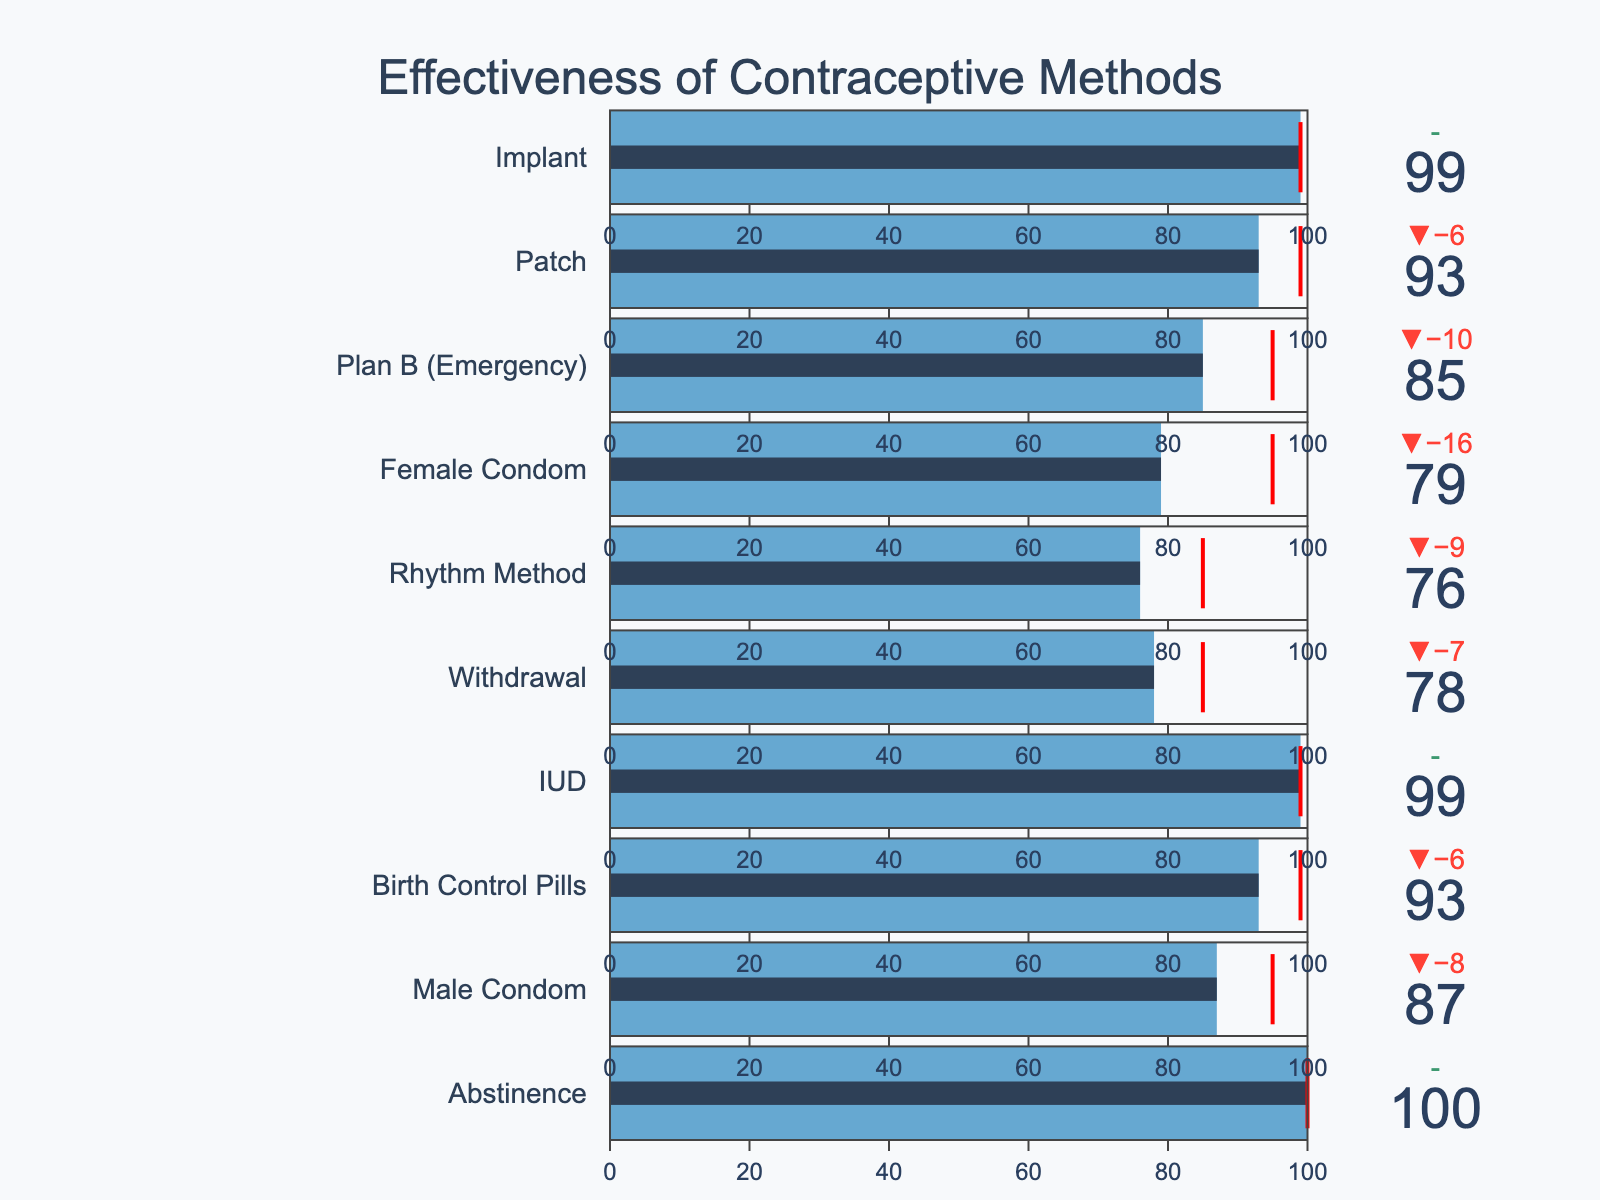How many contraceptive methods are shown in the chart? The figure lists each method along with its effectiveness values. Counting them gives the total number of methods.
Answer: 10 Which contraceptive method has the highest actual effectiveness? The figure shows the actual effectiveness of each method. Abstinence, IUD, and Implant all have 100% actual effectiveness, but since abstinence is listed first, it should be noted.
Answer: Abstinence Which method shows the largest gap between actual effectiveness and target effectiveness? By examining the delta indicator for each method, the largest gap in percentage is seen for Male Condom (87% actual vs. 95% target).
Answer: Male Condom What is the average actual effectiveness of all methods excluding abstinence? Sum the actual effectiveness values of all methods except abstinence (87+93+99+78+76+79+85+93+99) = 789, then divide by 9 methods.
Answer: 87.67 Which methods meet their target effectiveness? The methods whose actual effectiveness matches their target effectiveness are clearly indicated; these are the IUD, Implant, and Abstinence.
Answer: Abstinence, IUD, Implant What is the effectiveness difference between the Male Condom and the Female Condom? Examine the actual effectiveness values; for Male Condom, it is 87, and for Female Condom, it is 79. The difference is 87 - 79.
Answer: 8 Which method has the closest actual effectiveness to its target effectiveness without meeting it? By inspecting the delta values, Birth Control Pills have an actual effectiveness of 93% and a target of 99%, making a difference of 6%, the smallest difference without meeting the target.
Answer: Birth Control Pills What is the total of the target effectiveness values for all the methods? Summing all target effectiveness values gives (100+95+99+99+85+85+95+95+99+99). This equals 951.
Answer: 951 